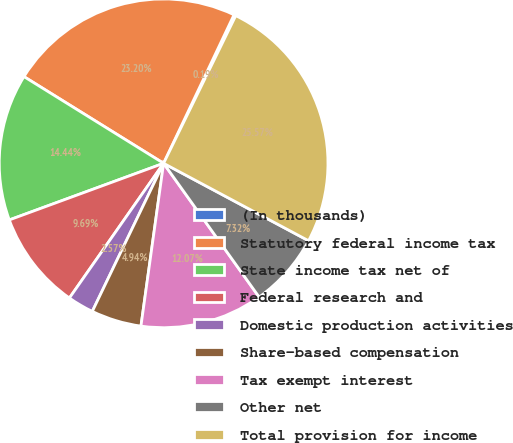<chart> <loc_0><loc_0><loc_500><loc_500><pie_chart><fcel>(In thousands)<fcel>Statutory federal income tax<fcel>State income tax net of<fcel>Federal research and<fcel>Domestic production activities<fcel>Share-based compensation<fcel>Tax exempt interest<fcel>Other net<fcel>Total provision for income<nl><fcel>0.19%<fcel>23.2%<fcel>14.44%<fcel>9.69%<fcel>2.57%<fcel>4.94%<fcel>12.07%<fcel>7.32%<fcel>25.57%<nl></chart> 